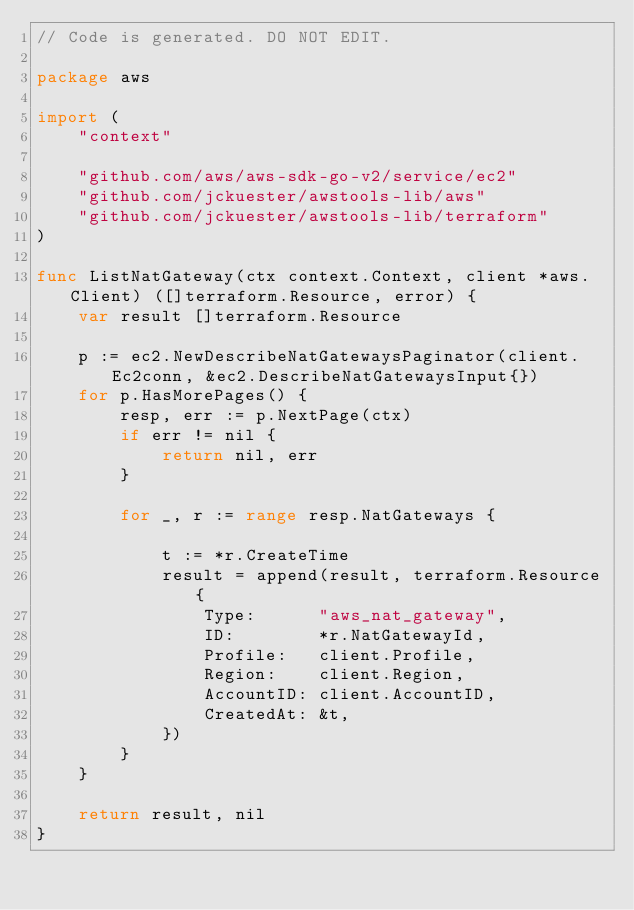Convert code to text. <code><loc_0><loc_0><loc_500><loc_500><_Go_>// Code is generated. DO NOT EDIT.

package aws

import (
	"context"

	"github.com/aws/aws-sdk-go-v2/service/ec2"
	"github.com/jckuester/awstools-lib/aws"
	"github.com/jckuester/awstools-lib/terraform"
)

func ListNatGateway(ctx context.Context, client *aws.Client) ([]terraform.Resource, error) {
	var result []terraform.Resource

	p := ec2.NewDescribeNatGatewaysPaginator(client.Ec2conn, &ec2.DescribeNatGatewaysInput{})
	for p.HasMorePages() {
		resp, err := p.NextPage(ctx)
		if err != nil {
			return nil, err
		}

		for _, r := range resp.NatGateways {

			t := *r.CreateTime
			result = append(result, terraform.Resource{
				Type:      "aws_nat_gateway",
				ID:        *r.NatGatewayId,
				Profile:   client.Profile,
				Region:    client.Region,
				AccountID: client.AccountID,
				CreatedAt: &t,
			})
		}
	}

	return result, nil
}
</code> 